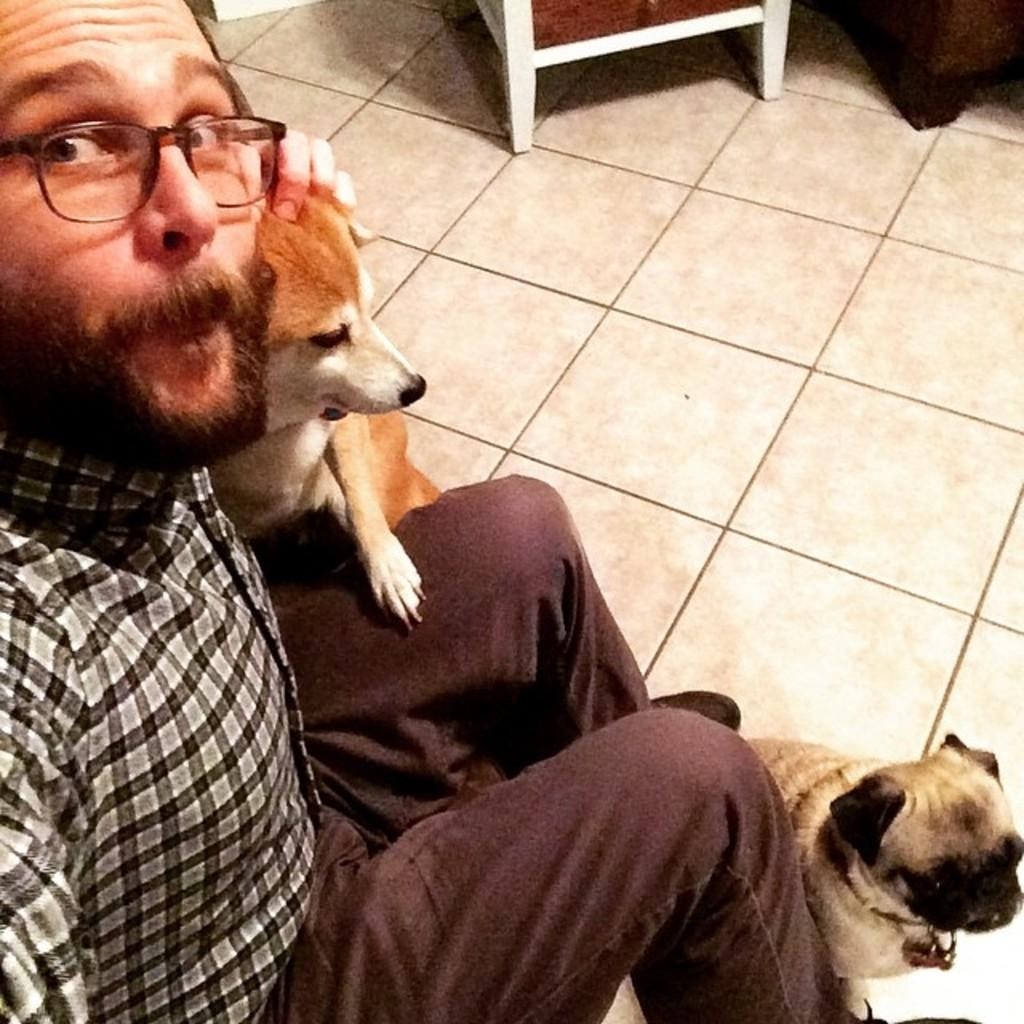What is the main subject of the image? The main subject of the image is a man. What is the man wearing in the image? The man is wearing spectacles in the image. What is the man doing with one of his hands? The man is holding a dog with one hand in the image. Are there any other animals present in the image? Yes, there is another dog at the man's legs in the image. What can be seen in the background of the image? There is a floor visible in the background of the image. What type of surprise is the man holding in the image? There is no surprise present in the image; the man is holding a dog with one hand. Can you tell me how many airplanes are visible in the image? There are no airplanes visible in the image. What disease is the man suffering from in the image? There is no indication of any disease in the image; the man is simply holding a dog with one hand. 